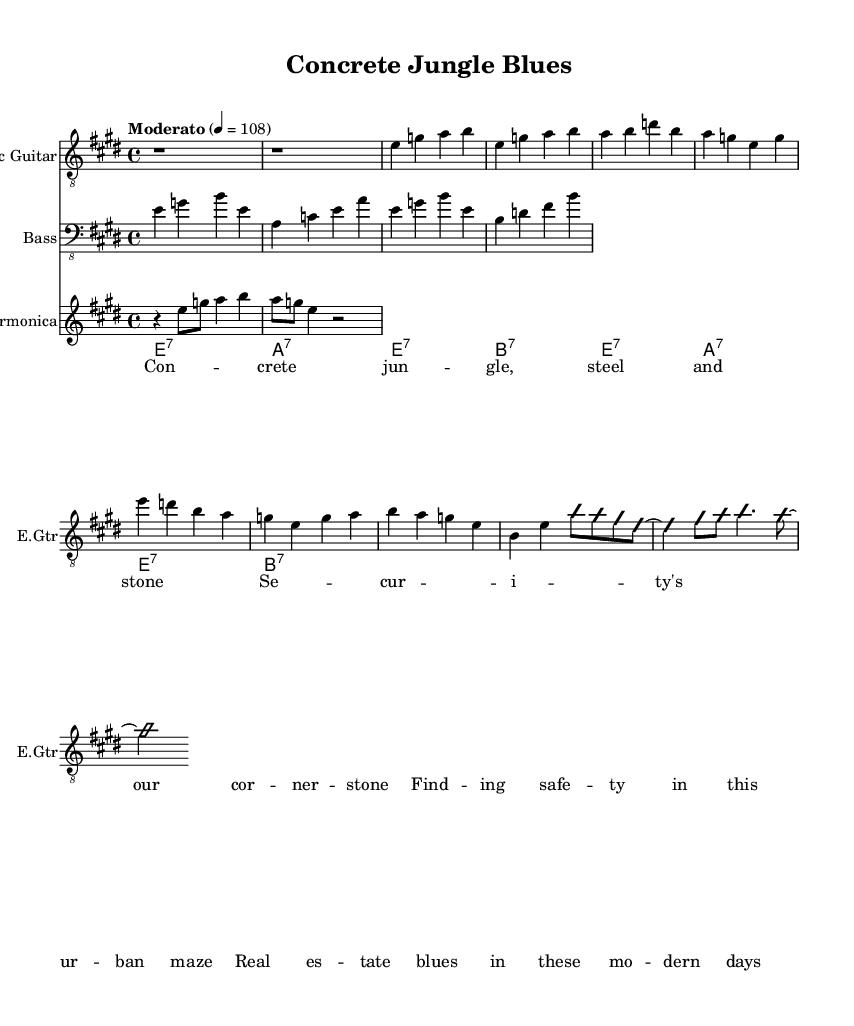What is the key signature of this music? The key signature is indicated as E major, which has four sharps (F#, C#, G#, D#).
Answer: E major What is the time signature of this music? The time signature is a standard 4/4, which allows four beats in each measure.
Answer: 4/4 What is the tempo marking for this piece? The tempo is marked as "Moderato," indicating a moderate speed of 108 beats per minute.
Answer: Moderato, 108 How many measures are in the verse section? The verse consists of 2 measures as indicated before the chorus section.
Answer: 2 What instruments are featured in this piece? The music features an electric guitar, bass, and harmonica as indicated in the score.
Answer: Electric guitar, bass, harmonica What improvisation is present in the music? The guitar solo section includes improvisation as indicated by the notation "improvisationOn" and "improvisationOff."
Answer: Guitar solo section What is the main theme expressed in the lyrics? The lyrics convey themes of urban challenges, safety, and real estate issues within a city environment.
Answer: Urban challenges, safety, real estate 